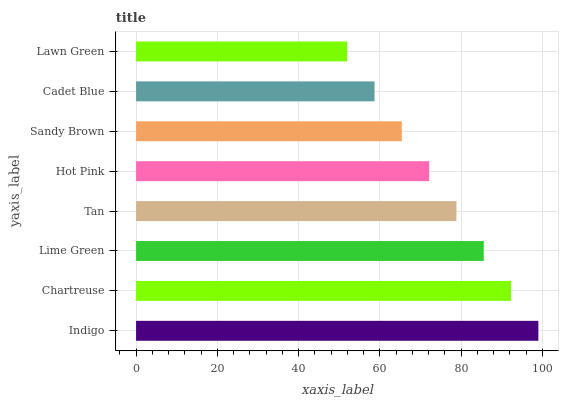Is Lawn Green the minimum?
Answer yes or no. Yes. Is Indigo the maximum?
Answer yes or no. Yes. Is Chartreuse the minimum?
Answer yes or no. No. Is Chartreuse the maximum?
Answer yes or no. No. Is Indigo greater than Chartreuse?
Answer yes or no. Yes. Is Chartreuse less than Indigo?
Answer yes or no. Yes. Is Chartreuse greater than Indigo?
Answer yes or no. No. Is Indigo less than Chartreuse?
Answer yes or no. No. Is Tan the high median?
Answer yes or no. Yes. Is Hot Pink the low median?
Answer yes or no. Yes. Is Cadet Blue the high median?
Answer yes or no. No. Is Sandy Brown the low median?
Answer yes or no. No. 